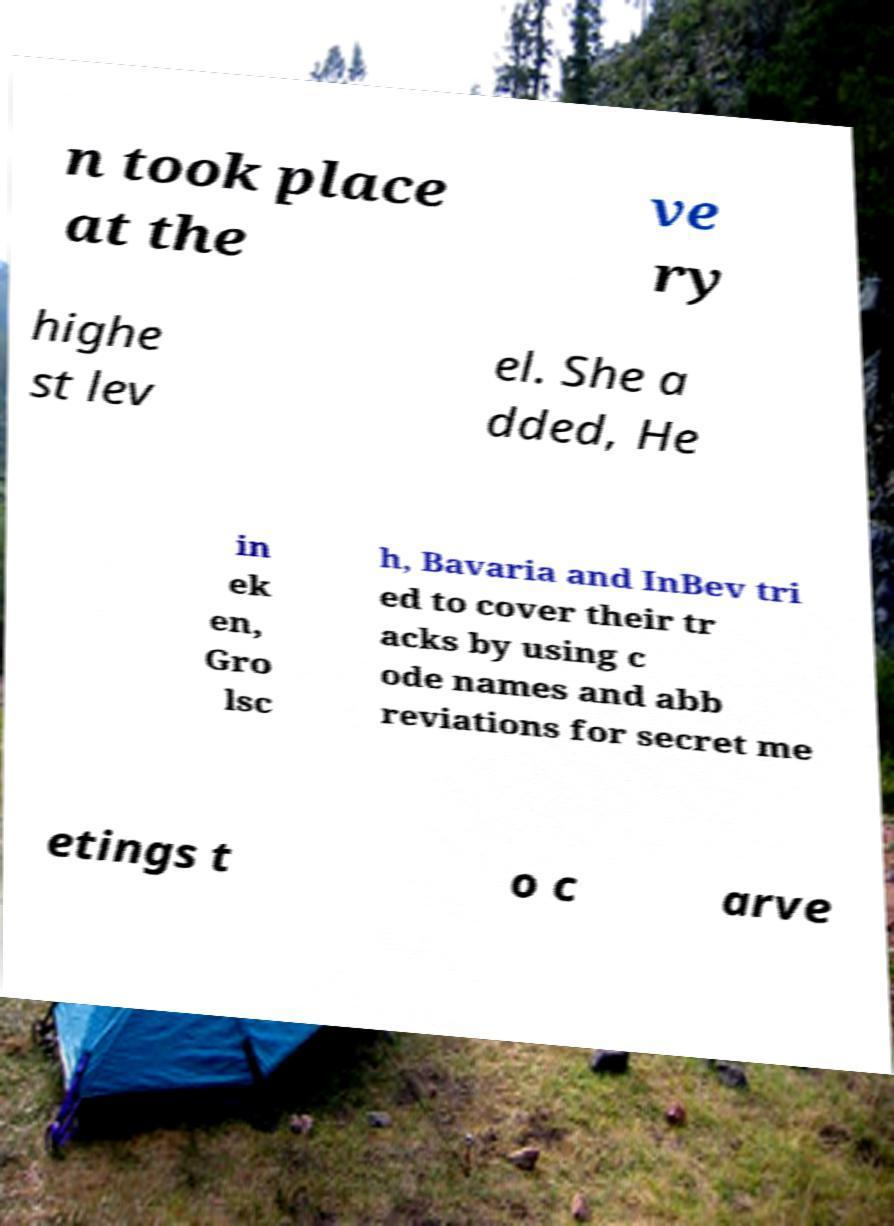What messages or text are displayed in this image? I need them in a readable, typed format. n took place at the ve ry highe st lev el. She a dded, He in ek en, Gro lsc h, Bavaria and InBev tri ed to cover their tr acks by using c ode names and abb reviations for secret me etings t o c arve 